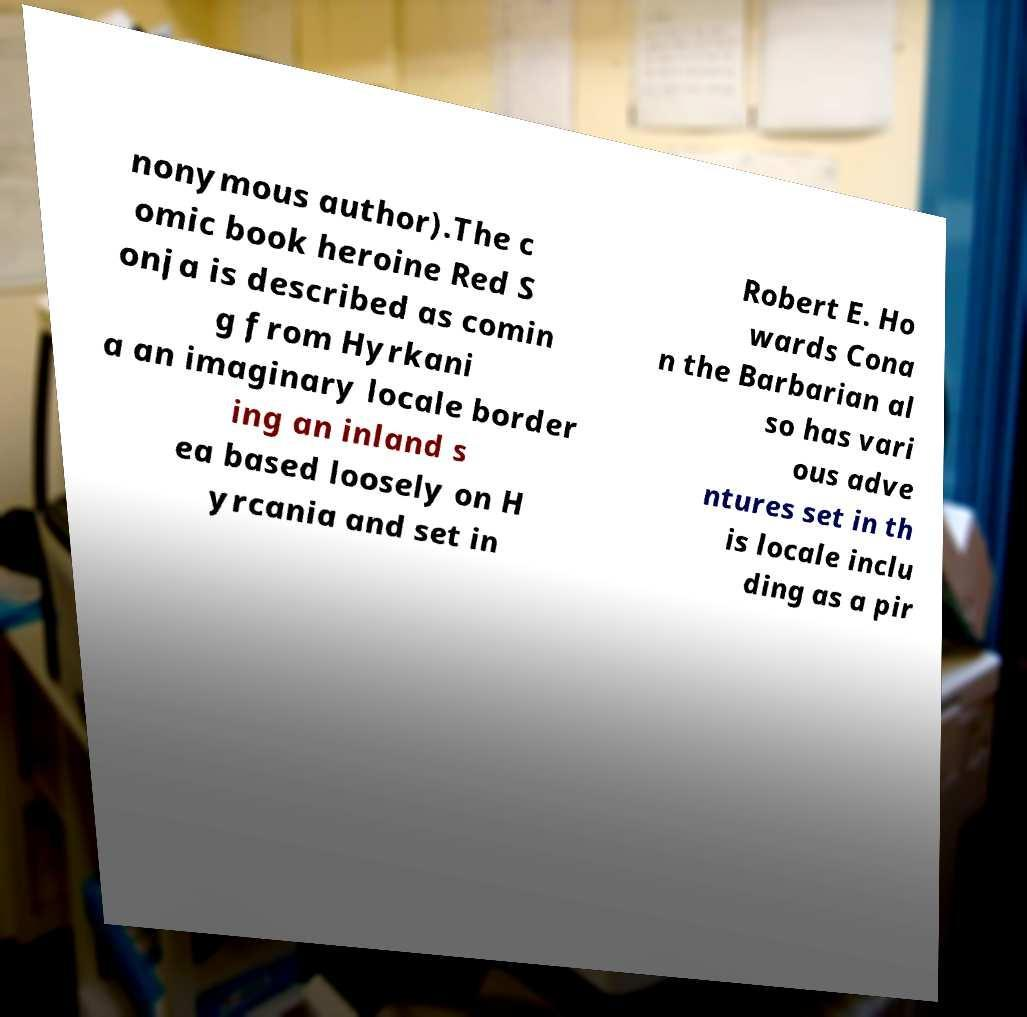Can you read and provide the text displayed in the image?This photo seems to have some interesting text. Can you extract and type it out for me? nonymous author).The c omic book heroine Red S onja is described as comin g from Hyrkani a an imaginary locale border ing an inland s ea based loosely on H yrcania and set in Robert E. Ho wards Cona n the Barbarian al so has vari ous adve ntures set in th is locale inclu ding as a pir 